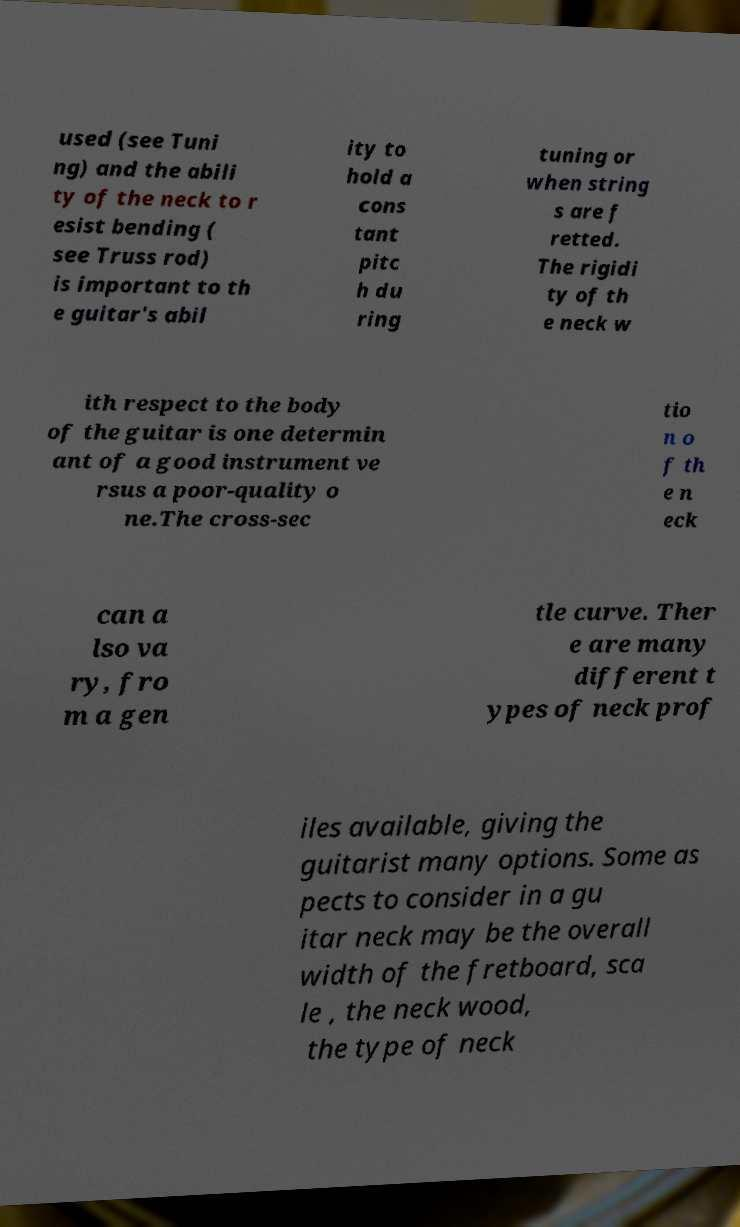Could you extract and type out the text from this image? used (see Tuni ng) and the abili ty of the neck to r esist bending ( see Truss rod) is important to th e guitar's abil ity to hold a cons tant pitc h du ring tuning or when string s are f retted. The rigidi ty of th e neck w ith respect to the body of the guitar is one determin ant of a good instrument ve rsus a poor-quality o ne.The cross-sec tio n o f th e n eck can a lso va ry, fro m a gen tle curve. Ther e are many different t ypes of neck prof iles available, giving the guitarist many options. Some as pects to consider in a gu itar neck may be the overall width of the fretboard, sca le , the neck wood, the type of neck 